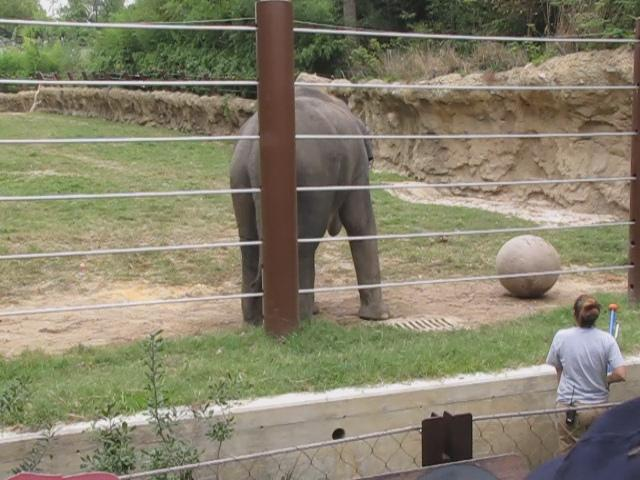How will she tell her supervisor about the welfare of the animal? Please explain your reasoning. walkie talkie. She has a handheld device hanging from her pocket 